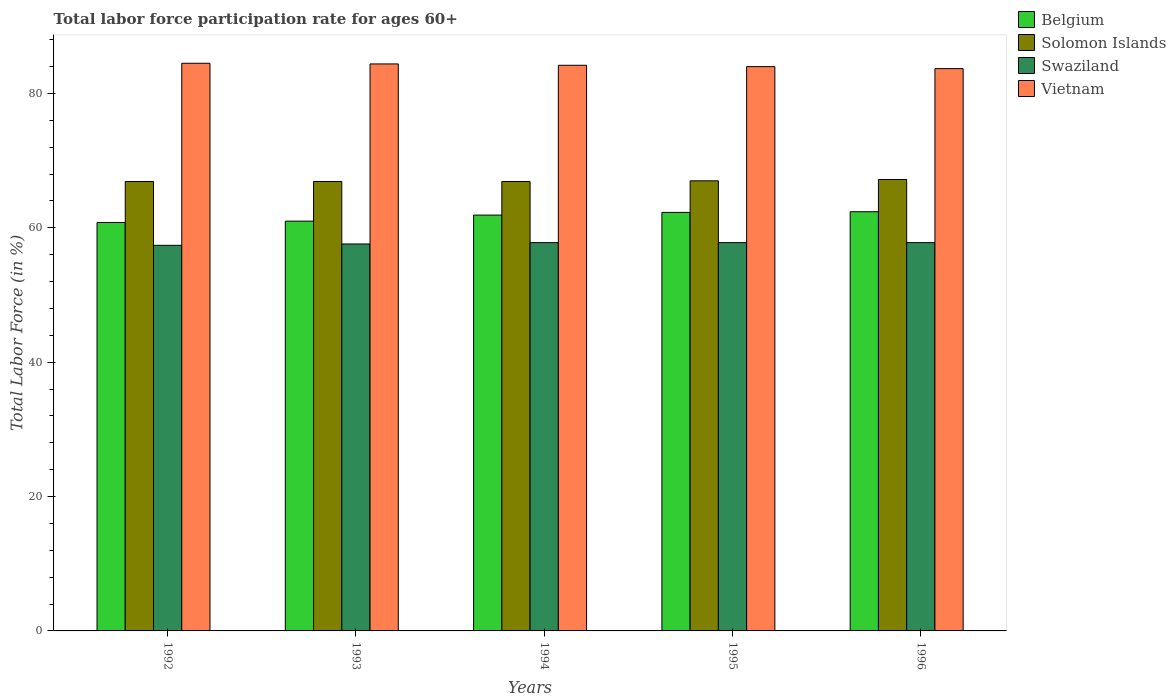How many different coloured bars are there?
Give a very brief answer. 4. Are the number of bars per tick equal to the number of legend labels?
Provide a short and direct response. Yes. How many bars are there on the 4th tick from the right?
Keep it short and to the point. 4. What is the labor force participation rate in Vietnam in 1994?
Your answer should be very brief. 84.2. Across all years, what is the maximum labor force participation rate in Swaziland?
Your answer should be very brief. 57.8. Across all years, what is the minimum labor force participation rate in Vietnam?
Make the answer very short. 83.7. In which year was the labor force participation rate in Swaziland maximum?
Offer a terse response. 1994. What is the total labor force participation rate in Vietnam in the graph?
Offer a terse response. 420.8. What is the difference between the labor force participation rate in Vietnam in 1994 and that in 1996?
Keep it short and to the point. 0.5. What is the difference between the labor force participation rate in Solomon Islands in 1994 and the labor force participation rate in Belgium in 1995?
Your answer should be compact. 4.6. What is the average labor force participation rate in Vietnam per year?
Offer a very short reply. 84.16. In the year 1992, what is the difference between the labor force participation rate in Swaziland and labor force participation rate in Belgium?
Make the answer very short. -3.4. What is the ratio of the labor force participation rate in Swaziland in 1992 to that in 1994?
Ensure brevity in your answer.  0.99. Is the labor force participation rate in Swaziland in 1993 less than that in 1996?
Provide a succinct answer. Yes. Is the difference between the labor force participation rate in Swaziland in 1992 and 1995 greater than the difference between the labor force participation rate in Belgium in 1992 and 1995?
Offer a terse response. Yes. What is the difference between the highest and the second highest labor force participation rate in Vietnam?
Offer a very short reply. 0.1. What is the difference between the highest and the lowest labor force participation rate in Belgium?
Ensure brevity in your answer.  1.6. Is the sum of the labor force participation rate in Solomon Islands in 1993 and 1995 greater than the maximum labor force participation rate in Swaziland across all years?
Make the answer very short. Yes. What does the 2nd bar from the left in 1995 represents?
Offer a terse response. Solomon Islands. How many years are there in the graph?
Ensure brevity in your answer.  5. Where does the legend appear in the graph?
Provide a short and direct response. Top right. How many legend labels are there?
Keep it short and to the point. 4. How are the legend labels stacked?
Offer a terse response. Vertical. What is the title of the graph?
Provide a short and direct response. Total labor force participation rate for ages 60+. What is the label or title of the Y-axis?
Make the answer very short. Total Labor Force (in %). What is the Total Labor Force (in %) in Belgium in 1992?
Give a very brief answer. 60.8. What is the Total Labor Force (in %) of Solomon Islands in 1992?
Make the answer very short. 66.9. What is the Total Labor Force (in %) in Swaziland in 1992?
Give a very brief answer. 57.4. What is the Total Labor Force (in %) in Vietnam in 1992?
Give a very brief answer. 84.5. What is the Total Labor Force (in %) in Belgium in 1993?
Your answer should be very brief. 61. What is the Total Labor Force (in %) in Solomon Islands in 1993?
Your answer should be very brief. 66.9. What is the Total Labor Force (in %) of Swaziland in 1993?
Give a very brief answer. 57.6. What is the Total Labor Force (in %) in Vietnam in 1993?
Your answer should be very brief. 84.4. What is the Total Labor Force (in %) of Belgium in 1994?
Your answer should be compact. 61.9. What is the Total Labor Force (in %) of Solomon Islands in 1994?
Offer a terse response. 66.9. What is the Total Labor Force (in %) in Swaziland in 1994?
Provide a succinct answer. 57.8. What is the Total Labor Force (in %) in Vietnam in 1994?
Provide a succinct answer. 84.2. What is the Total Labor Force (in %) in Belgium in 1995?
Offer a terse response. 62.3. What is the Total Labor Force (in %) of Solomon Islands in 1995?
Offer a terse response. 67. What is the Total Labor Force (in %) of Swaziland in 1995?
Make the answer very short. 57.8. What is the Total Labor Force (in %) of Belgium in 1996?
Keep it short and to the point. 62.4. What is the Total Labor Force (in %) in Solomon Islands in 1996?
Provide a succinct answer. 67.2. What is the Total Labor Force (in %) of Swaziland in 1996?
Your answer should be very brief. 57.8. What is the Total Labor Force (in %) in Vietnam in 1996?
Your answer should be very brief. 83.7. Across all years, what is the maximum Total Labor Force (in %) of Belgium?
Your response must be concise. 62.4. Across all years, what is the maximum Total Labor Force (in %) in Solomon Islands?
Your answer should be compact. 67.2. Across all years, what is the maximum Total Labor Force (in %) in Swaziland?
Your response must be concise. 57.8. Across all years, what is the maximum Total Labor Force (in %) in Vietnam?
Keep it short and to the point. 84.5. Across all years, what is the minimum Total Labor Force (in %) in Belgium?
Provide a succinct answer. 60.8. Across all years, what is the minimum Total Labor Force (in %) of Solomon Islands?
Your answer should be compact. 66.9. Across all years, what is the minimum Total Labor Force (in %) in Swaziland?
Offer a very short reply. 57.4. Across all years, what is the minimum Total Labor Force (in %) in Vietnam?
Provide a short and direct response. 83.7. What is the total Total Labor Force (in %) of Belgium in the graph?
Your response must be concise. 308.4. What is the total Total Labor Force (in %) of Solomon Islands in the graph?
Offer a terse response. 334.9. What is the total Total Labor Force (in %) in Swaziland in the graph?
Ensure brevity in your answer.  288.4. What is the total Total Labor Force (in %) of Vietnam in the graph?
Make the answer very short. 420.8. What is the difference between the Total Labor Force (in %) of Belgium in 1992 and that in 1993?
Your answer should be compact. -0.2. What is the difference between the Total Labor Force (in %) in Swaziland in 1992 and that in 1993?
Make the answer very short. -0.2. What is the difference between the Total Labor Force (in %) of Belgium in 1992 and that in 1994?
Ensure brevity in your answer.  -1.1. What is the difference between the Total Labor Force (in %) of Solomon Islands in 1992 and that in 1994?
Keep it short and to the point. 0. What is the difference between the Total Labor Force (in %) in Swaziland in 1992 and that in 1994?
Your answer should be very brief. -0.4. What is the difference between the Total Labor Force (in %) in Solomon Islands in 1992 and that in 1995?
Give a very brief answer. -0.1. What is the difference between the Total Labor Force (in %) in Swaziland in 1992 and that in 1995?
Your answer should be compact. -0.4. What is the difference between the Total Labor Force (in %) of Swaziland in 1992 and that in 1996?
Your answer should be compact. -0.4. What is the difference between the Total Labor Force (in %) in Vietnam in 1992 and that in 1996?
Your response must be concise. 0.8. What is the difference between the Total Labor Force (in %) of Belgium in 1993 and that in 1994?
Offer a terse response. -0.9. What is the difference between the Total Labor Force (in %) in Swaziland in 1993 and that in 1994?
Provide a short and direct response. -0.2. What is the difference between the Total Labor Force (in %) of Solomon Islands in 1993 and that in 1995?
Your answer should be very brief. -0.1. What is the difference between the Total Labor Force (in %) of Swaziland in 1993 and that in 1995?
Your answer should be compact. -0.2. What is the difference between the Total Labor Force (in %) in Belgium in 1993 and that in 1996?
Your answer should be very brief. -1.4. What is the difference between the Total Labor Force (in %) in Solomon Islands in 1993 and that in 1996?
Keep it short and to the point. -0.3. What is the difference between the Total Labor Force (in %) of Swaziland in 1993 and that in 1996?
Keep it short and to the point. -0.2. What is the difference between the Total Labor Force (in %) of Vietnam in 1993 and that in 1996?
Your answer should be compact. 0.7. What is the difference between the Total Labor Force (in %) of Belgium in 1994 and that in 1996?
Provide a short and direct response. -0.5. What is the difference between the Total Labor Force (in %) of Belgium in 1995 and that in 1996?
Provide a succinct answer. -0.1. What is the difference between the Total Labor Force (in %) in Vietnam in 1995 and that in 1996?
Keep it short and to the point. 0.3. What is the difference between the Total Labor Force (in %) in Belgium in 1992 and the Total Labor Force (in %) in Solomon Islands in 1993?
Your answer should be very brief. -6.1. What is the difference between the Total Labor Force (in %) of Belgium in 1992 and the Total Labor Force (in %) of Vietnam in 1993?
Your answer should be very brief. -23.6. What is the difference between the Total Labor Force (in %) of Solomon Islands in 1992 and the Total Labor Force (in %) of Vietnam in 1993?
Ensure brevity in your answer.  -17.5. What is the difference between the Total Labor Force (in %) of Swaziland in 1992 and the Total Labor Force (in %) of Vietnam in 1993?
Offer a very short reply. -27. What is the difference between the Total Labor Force (in %) in Belgium in 1992 and the Total Labor Force (in %) in Solomon Islands in 1994?
Give a very brief answer. -6.1. What is the difference between the Total Labor Force (in %) of Belgium in 1992 and the Total Labor Force (in %) of Swaziland in 1994?
Your answer should be very brief. 3. What is the difference between the Total Labor Force (in %) in Belgium in 1992 and the Total Labor Force (in %) in Vietnam in 1994?
Keep it short and to the point. -23.4. What is the difference between the Total Labor Force (in %) of Solomon Islands in 1992 and the Total Labor Force (in %) of Swaziland in 1994?
Your answer should be compact. 9.1. What is the difference between the Total Labor Force (in %) of Solomon Islands in 1992 and the Total Labor Force (in %) of Vietnam in 1994?
Offer a very short reply. -17.3. What is the difference between the Total Labor Force (in %) of Swaziland in 1992 and the Total Labor Force (in %) of Vietnam in 1994?
Your response must be concise. -26.8. What is the difference between the Total Labor Force (in %) of Belgium in 1992 and the Total Labor Force (in %) of Solomon Islands in 1995?
Provide a succinct answer. -6.2. What is the difference between the Total Labor Force (in %) of Belgium in 1992 and the Total Labor Force (in %) of Swaziland in 1995?
Offer a very short reply. 3. What is the difference between the Total Labor Force (in %) of Belgium in 1992 and the Total Labor Force (in %) of Vietnam in 1995?
Your response must be concise. -23.2. What is the difference between the Total Labor Force (in %) of Solomon Islands in 1992 and the Total Labor Force (in %) of Vietnam in 1995?
Keep it short and to the point. -17.1. What is the difference between the Total Labor Force (in %) in Swaziland in 1992 and the Total Labor Force (in %) in Vietnam in 1995?
Give a very brief answer. -26.6. What is the difference between the Total Labor Force (in %) of Belgium in 1992 and the Total Labor Force (in %) of Swaziland in 1996?
Your response must be concise. 3. What is the difference between the Total Labor Force (in %) in Belgium in 1992 and the Total Labor Force (in %) in Vietnam in 1996?
Your answer should be compact. -22.9. What is the difference between the Total Labor Force (in %) of Solomon Islands in 1992 and the Total Labor Force (in %) of Swaziland in 1996?
Make the answer very short. 9.1. What is the difference between the Total Labor Force (in %) in Solomon Islands in 1992 and the Total Labor Force (in %) in Vietnam in 1996?
Give a very brief answer. -16.8. What is the difference between the Total Labor Force (in %) of Swaziland in 1992 and the Total Labor Force (in %) of Vietnam in 1996?
Your answer should be very brief. -26.3. What is the difference between the Total Labor Force (in %) in Belgium in 1993 and the Total Labor Force (in %) in Swaziland in 1994?
Keep it short and to the point. 3.2. What is the difference between the Total Labor Force (in %) in Belgium in 1993 and the Total Labor Force (in %) in Vietnam in 1994?
Give a very brief answer. -23.2. What is the difference between the Total Labor Force (in %) of Solomon Islands in 1993 and the Total Labor Force (in %) of Swaziland in 1994?
Give a very brief answer. 9.1. What is the difference between the Total Labor Force (in %) of Solomon Islands in 1993 and the Total Labor Force (in %) of Vietnam in 1994?
Give a very brief answer. -17.3. What is the difference between the Total Labor Force (in %) of Swaziland in 1993 and the Total Labor Force (in %) of Vietnam in 1994?
Make the answer very short. -26.6. What is the difference between the Total Labor Force (in %) in Solomon Islands in 1993 and the Total Labor Force (in %) in Swaziland in 1995?
Provide a short and direct response. 9.1. What is the difference between the Total Labor Force (in %) of Solomon Islands in 1993 and the Total Labor Force (in %) of Vietnam in 1995?
Your answer should be compact. -17.1. What is the difference between the Total Labor Force (in %) of Swaziland in 1993 and the Total Labor Force (in %) of Vietnam in 1995?
Give a very brief answer. -26.4. What is the difference between the Total Labor Force (in %) in Belgium in 1993 and the Total Labor Force (in %) in Solomon Islands in 1996?
Provide a short and direct response. -6.2. What is the difference between the Total Labor Force (in %) of Belgium in 1993 and the Total Labor Force (in %) of Vietnam in 1996?
Make the answer very short. -22.7. What is the difference between the Total Labor Force (in %) in Solomon Islands in 1993 and the Total Labor Force (in %) in Vietnam in 1996?
Keep it short and to the point. -16.8. What is the difference between the Total Labor Force (in %) of Swaziland in 1993 and the Total Labor Force (in %) of Vietnam in 1996?
Make the answer very short. -26.1. What is the difference between the Total Labor Force (in %) in Belgium in 1994 and the Total Labor Force (in %) in Vietnam in 1995?
Offer a very short reply. -22.1. What is the difference between the Total Labor Force (in %) of Solomon Islands in 1994 and the Total Labor Force (in %) of Swaziland in 1995?
Offer a terse response. 9.1. What is the difference between the Total Labor Force (in %) in Solomon Islands in 1994 and the Total Labor Force (in %) in Vietnam in 1995?
Offer a very short reply. -17.1. What is the difference between the Total Labor Force (in %) of Swaziland in 1994 and the Total Labor Force (in %) of Vietnam in 1995?
Provide a succinct answer. -26.2. What is the difference between the Total Labor Force (in %) in Belgium in 1994 and the Total Labor Force (in %) in Swaziland in 1996?
Offer a very short reply. 4.1. What is the difference between the Total Labor Force (in %) in Belgium in 1994 and the Total Labor Force (in %) in Vietnam in 1996?
Make the answer very short. -21.8. What is the difference between the Total Labor Force (in %) of Solomon Islands in 1994 and the Total Labor Force (in %) of Swaziland in 1996?
Make the answer very short. 9.1. What is the difference between the Total Labor Force (in %) of Solomon Islands in 1994 and the Total Labor Force (in %) of Vietnam in 1996?
Offer a very short reply. -16.8. What is the difference between the Total Labor Force (in %) of Swaziland in 1994 and the Total Labor Force (in %) of Vietnam in 1996?
Your answer should be compact. -25.9. What is the difference between the Total Labor Force (in %) in Belgium in 1995 and the Total Labor Force (in %) in Solomon Islands in 1996?
Ensure brevity in your answer.  -4.9. What is the difference between the Total Labor Force (in %) of Belgium in 1995 and the Total Labor Force (in %) of Vietnam in 1996?
Make the answer very short. -21.4. What is the difference between the Total Labor Force (in %) of Solomon Islands in 1995 and the Total Labor Force (in %) of Vietnam in 1996?
Offer a terse response. -16.7. What is the difference between the Total Labor Force (in %) in Swaziland in 1995 and the Total Labor Force (in %) in Vietnam in 1996?
Offer a very short reply. -25.9. What is the average Total Labor Force (in %) of Belgium per year?
Your response must be concise. 61.68. What is the average Total Labor Force (in %) of Solomon Islands per year?
Offer a very short reply. 66.98. What is the average Total Labor Force (in %) in Swaziland per year?
Your response must be concise. 57.68. What is the average Total Labor Force (in %) of Vietnam per year?
Offer a terse response. 84.16. In the year 1992, what is the difference between the Total Labor Force (in %) in Belgium and Total Labor Force (in %) in Swaziland?
Ensure brevity in your answer.  3.4. In the year 1992, what is the difference between the Total Labor Force (in %) of Belgium and Total Labor Force (in %) of Vietnam?
Keep it short and to the point. -23.7. In the year 1992, what is the difference between the Total Labor Force (in %) in Solomon Islands and Total Labor Force (in %) in Swaziland?
Offer a very short reply. 9.5. In the year 1992, what is the difference between the Total Labor Force (in %) of Solomon Islands and Total Labor Force (in %) of Vietnam?
Provide a succinct answer. -17.6. In the year 1992, what is the difference between the Total Labor Force (in %) in Swaziland and Total Labor Force (in %) in Vietnam?
Provide a succinct answer. -27.1. In the year 1993, what is the difference between the Total Labor Force (in %) in Belgium and Total Labor Force (in %) in Solomon Islands?
Keep it short and to the point. -5.9. In the year 1993, what is the difference between the Total Labor Force (in %) of Belgium and Total Labor Force (in %) of Vietnam?
Your answer should be very brief. -23.4. In the year 1993, what is the difference between the Total Labor Force (in %) of Solomon Islands and Total Labor Force (in %) of Vietnam?
Provide a succinct answer. -17.5. In the year 1993, what is the difference between the Total Labor Force (in %) in Swaziland and Total Labor Force (in %) in Vietnam?
Provide a succinct answer. -26.8. In the year 1994, what is the difference between the Total Labor Force (in %) in Belgium and Total Labor Force (in %) in Solomon Islands?
Your answer should be compact. -5. In the year 1994, what is the difference between the Total Labor Force (in %) in Belgium and Total Labor Force (in %) in Swaziland?
Make the answer very short. 4.1. In the year 1994, what is the difference between the Total Labor Force (in %) of Belgium and Total Labor Force (in %) of Vietnam?
Offer a terse response. -22.3. In the year 1994, what is the difference between the Total Labor Force (in %) of Solomon Islands and Total Labor Force (in %) of Vietnam?
Ensure brevity in your answer.  -17.3. In the year 1994, what is the difference between the Total Labor Force (in %) in Swaziland and Total Labor Force (in %) in Vietnam?
Give a very brief answer. -26.4. In the year 1995, what is the difference between the Total Labor Force (in %) in Belgium and Total Labor Force (in %) in Vietnam?
Make the answer very short. -21.7. In the year 1995, what is the difference between the Total Labor Force (in %) of Solomon Islands and Total Labor Force (in %) of Swaziland?
Provide a succinct answer. 9.2. In the year 1995, what is the difference between the Total Labor Force (in %) in Solomon Islands and Total Labor Force (in %) in Vietnam?
Make the answer very short. -17. In the year 1995, what is the difference between the Total Labor Force (in %) in Swaziland and Total Labor Force (in %) in Vietnam?
Make the answer very short. -26.2. In the year 1996, what is the difference between the Total Labor Force (in %) in Belgium and Total Labor Force (in %) in Solomon Islands?
Provide a short and direct response. -4.8. In the year 1996, what is the difference between the Total Labor Force (in %) of Belgium and Total Labor Force (in %) of Vietnam?
Ensure brevity in your answer.  -21.3. In the year 1996, what is the difference between the Total Labor Force (in %) in Solomon Islands and Total Labor Force (in %) in Swaziland?
Provide a succinct answer. 9.4. In the year 1996, what is the difference between the Total Labor Force (in %) of Solomon Islands and Total Labor Force (in %) of Vietnam?
Give a very brief answer. -16.5. In the year 1996, what is the difference between the Total Labor Force (in %) in Swaziland and Total Labor Force (in %) in Vietnam?
Your response must be concise. -25.9. What is the ratio of the Total Labor Force (in %) of Solomon Islands in 1992 to that in 1993?
Ensure brevity in your answer.  1. What is the ratio of the Total Labor Force (in %) in Vietnam in 1992 to that in 1993?
Ensure brevity in your answer.  1. What is the ratio of the Total Labor Force (in %) of Belgium in 1992 to that in 1994?
Offer a terse response. 0.98. What is the ratio of the Total Labor Force (in %) in Solomon Islands in 1992 to that in 1994?
Make the answer very short. 1. What is the ratio of the Total Labor Force (in %) in Swaziland in 1992 to that in 1994?
Give a very brief answer. 0.99. What is the ratio of the Total Labor Force (in %) of Belgium in 1992 to that in 1995?
Give a very brief answer. 0.98. What is the ratio of the Total Labor Force (in %) of Vietnam in 1992 to that in 1995?
Your answer should be compact. 1.01. What is the ratio of the Total Labor Force (in %) in Belgium in 1992 to that in 1996?
Ensure brevity in your answer.  0.97. What is the ratio of the Total Labor Force (in %) of Solomon Islands in 1992 to that in 1996?
Offer a very short reply. 1. What is the ratio of the Total Labor Force (in %) of Vietnam in 1992 to that in 1996?
Your answer should be very brief. 1.01. What is the ratio of the Total Labor Force (in %) in Belgium in 1993 to that in 1994?
Give a very brief answer. 0.99. What is the ratio of the Total Labor Force (in %) in Vietnam in 1993 to that in 1994?
Offer a very short reply. 1. What is the ratio of the Total Labor Force (in %) of Belgium in 1993 to that in 1995?
Offer a terse response. 0.98. What is the ratio of the Total Labor Force (in %) in Solomon Islands in 1993 to that in 1995?
Ensure brevity in your answer.  1. What is the ratio of the Total Labor Force (in %) in Swaziland in 1993 to that in 1995?
Your response must be concise. 1. What is the ratio of the Total Labor Force (in %) in Belgium in 1993 to that in 1996?
Provide a succinct answer. 0.98. What is the ratio of the Total Labor Force (in %) of Vietnam in 1993 to that in 1996?
Make the answer very short. 1.01. What is the ratio of the Total Labor Force (in %) in Solomon Islands in 1994 to that in 1996?
Give a very brief answer. 1. What is the ratio of the Total Labor Force (in %) in Swaziland in 1994 to that in 1996?
Offer a terse response. 1. What is the ratio of the Total Labor Force (in %) of Vietnam in 1995 to that in 1996?
Your response must be concise. 1. What is the difference between the highest and the second highest Total Labor Force (in %) in Solomon Islands?
Your answer should be compact. 0.2. What is the difference between the highest and the second highest Total Labor Force (in %) of Vietnam?
Offer a very short reply. 0.1. What is the difference between the highest and the lowest Total Labor Force (in %) of Solomon Islands?
Your answer should be very brief. 0.3. What is the difference between the highest and the lowest Total Labor Force (in %) of Swaziland?
Give a very brief answer. 0.4. What is the difference between the highest and the lowest Total Labor Force (in %) in Vietnam?
Provide a short and direct response. 0.8. 